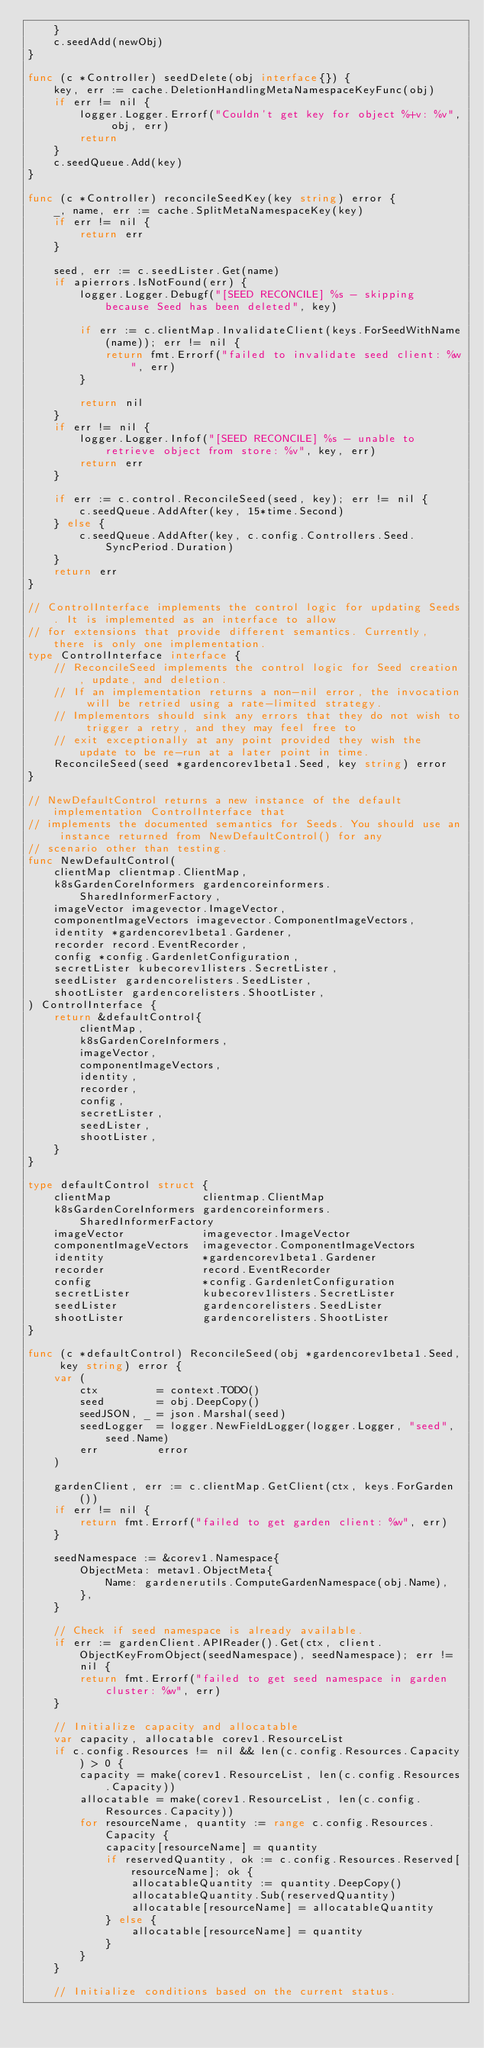Convert code to text. <code><loc_0><loc_0><loc_500><loc_500><_Go_>	}
	c.seedAdd(newObj)
}

func (c *Controller) seedDelete(obj interface{}) {
	key, err := cache.DeletionHandlingMetaNamespaceKeyFunc(obj)
	if err != nil {
		logger.Logger.Errorf("Couldn't get key for object %+v: %v", obj, err)
		return
	}
	c.seedQueue.Add(key)
}

func (c *Controller) reconcileSeedKey(key string) error {
	_, name, err := cache.SplitMetaNamespaceKey(key)
	if err != nil {
		return err
	}

	seed, err := c.seedLister.Get(name)
	if apierrors.IsNotFound(err) {
		logger.Logger.Debugf("[SEED RECONCILE] %s - skipping because Seed has been deleted", key)

		if err := c.clientMap.InvalidateClient(keys.ForSeedWithName(name)); err != nil {
			return fmt.Errorf("failed to invalidate seed client: %w", err)
		}

		return nil
	}
	if err != nil {
		logger.Logger.Infof("[SEED RECONCILE] %s - unable to retrieve object from store: %v", key, err)
		return err
	}

	if err := c.control.ReconcileSeed(seed, key); err != nil {
		c.seedQueue.AddAfter(key, 15*time.Second)
	} else {
		c.seedQueue.AddAfter(key, c.config.Controllers.Seed.SyncPeriod.Duration)
	}
	return err
}

// ControlInterface implements the control logic for updating Seeds. It is implemented as an interface to allow
// for extensions that provide different semantics. Currently, there is only one implementation.
type ControlInterface interface {
	// ReconcileSeed implements the control logic for Seed creation, update, and deletion.
	// If an implementation returns a non-nil error, the invocation will be retried using a rate-limited strategy.
	// Implementors should sink any errors that they do not wish to trigger a retry, and they may feel free to
	// exit exceptionally at any point provided they wish the update to be re-run at a later point in time.
	ReconcileSeed(seed *gardencorev1beta1.Seed, key string) error
}

// NewDefaultControl returns a new instance of the default implementation ControlInterface that
// implements the documented semantics for Seeds. You should use an instance returned from NewDefaultControl() for any
// scenario other than testing.
func NewDefaultControl(
	clientMap clientmap.ClientMap,
	k8sGardenCoreInformers gardencoreinformers.SharedInformerFactory,
	imageVector imagevector.ImageVector,
	componentImageVectors imagevector.ComponentImageVectors,
	identity *gardencorev1beta1.Gardener,
	recorder record.EventRecorder,
	config *config.GardenletConfiguration,
	secretLister kubecorev1listers.SecretLister,
	seedLister gardencorelisters.SeedLister,
	shootLister gardencorelisters.ShootLister,
) ControlInterface {
	return &defaultControl{
		clientMap,
		k8sGardenCoreInformers,
		imageVector,
		componentImageVectors,
		identity,
		recorder,
		config,
		secretLister,
		seedLister,
		shootLister,
	}
}

type defaultControl struct {
	clientMap              clientmap.ClientMap
	k8sGardenCoreInformers gardencoreinformers.SharedInformerFactory
	imageVector            imagevector.ImageVector
	componentImageVectors  imagevector.ComponentImageVectors
	identity               *gardencorev1beta1.Gardener
	recorder               record.EventRecorder
	config                 *config.GardenletConfiguration
	secretLister           kubecorev1listers.SecretLister
	seedLister             gardencorelisters.SeedLister
	shootLister            gardencorelisters.ShootLister
}

func (c *defaultControl) ReconcileSeed(obj *gardencorev1beta1.Seed, key string) error {
	var (
		ctx         = context.TODO()
		seed        = obj.DeepCopy()
		seedJSON, _ = json.Marshal(seed)
		seedLogger  = logger.NewFieldLogger(logger.Logger, "seed", seed.Name)
		err         error
	)

	gardenClient, err := c.clientMap.GetClient(ctx, keys.ForGarden())
	if err != nil {
		return fmt.Errorf("failed to get garden client: %w", err)
	}

	seedNamespace := &corev1.Namespace{
		ObjectMeta: metav1.ObjectMeta{
			Name: gardenerutils.ComputeGardenNamespace(obj.Name),
		},
	}

	// Check if seed namespace is already available.
	if err := gardenClient.APIReader().Get(ctx, client.ObjectKeyFromObject(seedNamespace), seedNamespace); err != nil {
		return fmt.Errorf("failed to get seed namespace in garden cluster: %w", err)
	}

	// Initialize capacity and allocatable
	var capacity, allocatable corev1.ResourceList
	if c.config.Resources != nil && len(c.config.Resources.Capacity) > 0 {
		capacity = make(corev1.ResourceList, len(c.config.Resources.Capacity))
		allocatable = make(corev1.ResourceList, len(c.config.Resources.Capacity))
		for resourceName, quantity := range c.config.Resources.Capacity {
			capacity[resourceName] = quantity
			if reservedQuantity, ok := c.config.Resources.Reserved[resourceName]; ok {
				allocatableQuantity := quantity.DeepCopy()
				allocatableQuantity.Sub(reservedQuantity)
				allocatable[resourceName] = allocatableQuantity
			} else {
				allocatable[resourceName] = quantity
			}
		}
	}

	// Initialize conditions based on the current status.</code> 